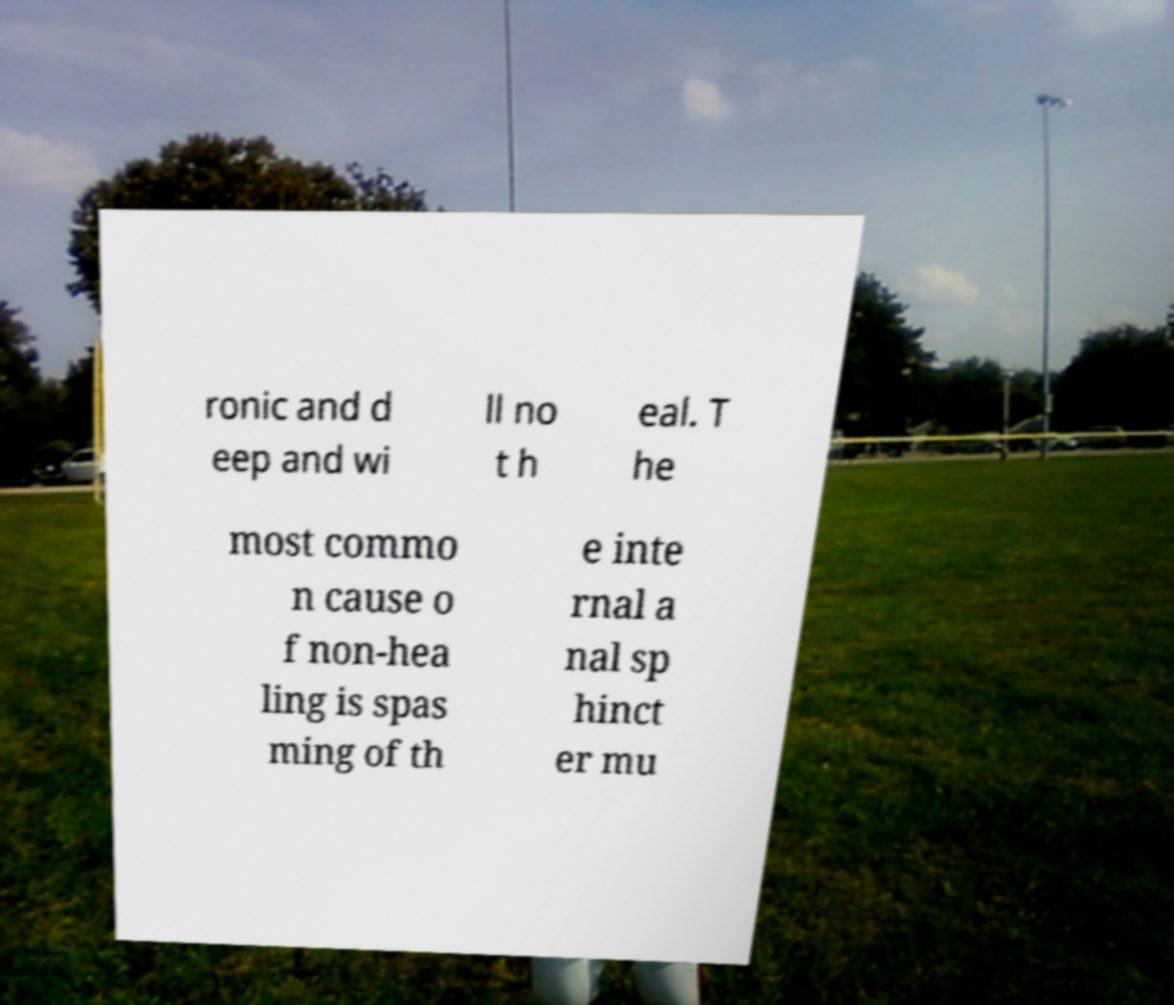Could you assist in decoding the text presented in this image and type it out clearly? ronic and d eep and wi ll no t h eal. T he most commo n cause o f non-hea ling is spas ming of th e inte rnal a nal sp hinct er mu 